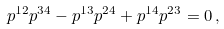<formula> <loc_0><loc_0><loc_500><loc_500>p ^ { 1 2 } p ^ { 3 4 } - p ^ { 1 3 } p ^ { 2 4 } + p ^ { 1 4 } p ^ { 2 3 } = 0 \, ,</formula> 